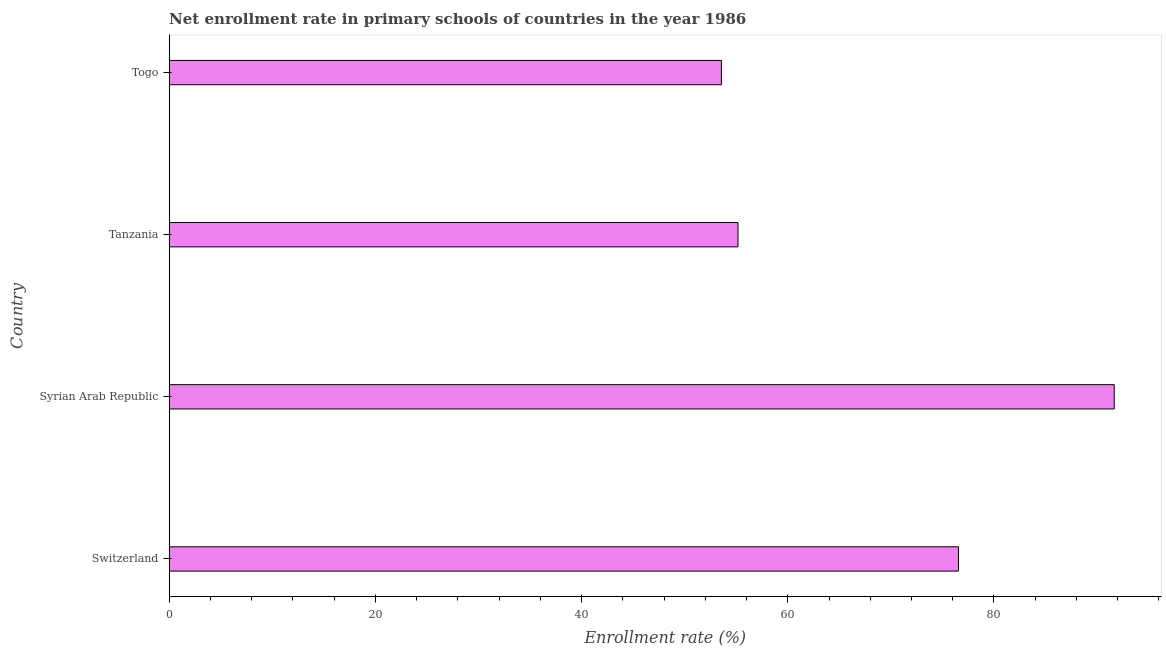Does the graph contain grids?
Your response must be concise. No. What is the title of the graph?
Make the answer very short. Net enrollment rate in primary schools of countries in the year 1986. What is the label or title of the X-axis?
Provide a succinct answer. Enrollment rate (%). What is the net enrollment rate in primary schools in Syrian Arab Republic?
Make the answer very short. 91.66. Across all countries, what is the maximum net enrollment rate in primary schools?
Your answer should be compact. 91.66. Across all countries, what is the minimum net enrollment rate in primary schools?
Provide a succinct answer. 53.56. In which country was the net enrollment rate in primary schools maximum?
Ensure brevity in your answer.  Syrian Arab Republic. In which country was the net enrollment rate in primary schools minimum?
Keep it short and to the point. Togo. What is the sum of the net enrollment rate in primary schools?
Offer a terse response. 276.95. What is the difference between the net enrollment rate in primary schools in Switzerland and Togo?
Make the answer very short. 23. What is the average net enrollment rate in primary schools per country?
Your response must be concise. 69.24. What is the median net enrollment rate in primary schools?
Give a very brief answer. 65.86. What is the ratio of the net enrollment rate in primary schools in Syrian Arab Republic to that in Togo?
Offer a very short reply. 1.71. Is the net enrollment rate in primary schools in Switzerland less than that in Togo?
Ensure brevity in your answer.  No. What is the difference between the highest and the second highest net enrollment rate in primary schools?
Make the answer very short. 15.11. Is the sum of the net enrollment rate in primary schools in Switzerland and Syrian Arab Republic greater than the maximum net enrollment rate in primary schools across all countries?
Ensure brevity in your answer.  Yes. What is the difference between the highest and the lowest net enrollment rate in primary schools?
Give a very brief answer. 38.1. Are all the bars in the graph horizontal?
Your answer should be very brief. Yes. What is the Enrollment rate (%) in Switzerland?
Give a very brief answer. 76.56. What is the Enrollment rate (%) in Syrian Arab Republic?
Your response must be concise. 91.66. What is the Enrollment rate (%) of Tanzania?
Provide a short and direct response. 55.17. What is the Enrollment rate (%) in Togo?
Make the answer very short. 53.56. What is the difference between the Enrollment rate (%) in Switzerland and Syrian Arab Republic?
Give a very brief answer. -15.11. What is the difference between the Enrollment rate (%) in Switzerland and Tanzania?
Ensure brevity in your answer.  21.39. What is the difference between the Enrollment rate (%) in Switzerland and Togo?
Make the answer very short. 23. What is the difference between the Enrollment rate (%) in Syrian Arab Republic and Tanzania?
Your response must be concise. 36.5. What is the difference between the Enrollment rate (%) in Syrian Arab Republic and Togo?
Your answer should be compact. 38.1. What is the difference between the Enrollment rate (%) in Tanzania and Togo?
Keep it short and to the point. 1.61. What is the ratio of the Enrollment rate (%) in Switzerland to that in Syrian Arab Republic?
Offer a very short reply. 0.83. What is the ratio of the Enrollment rate (%) in Switzerland to that in Tanzania?
Provide a succinct answer. 1.39. What is the ratio of the Enrollment rate (%) in Switzerland to that in Togo?
Your response must be concise. 1.43. What is the ratio of the Enrollment rate (%) in Syrian Arab Republic to that in Tanzania?
Provide a succinct answer. 1.66. What is the ratio of the Enrollment rate (%) in Syrian Arab Republic to that in Togo?
Your response must be concise. 1.71. What is the ratio of the Enrollment rate (%) in Tanzania to that in Togo?
Ensure brevity in your answer.  1.03. 